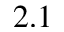<formula> <loc_0><loc_0><loc_500><loc_500>2 . 1</formula> 